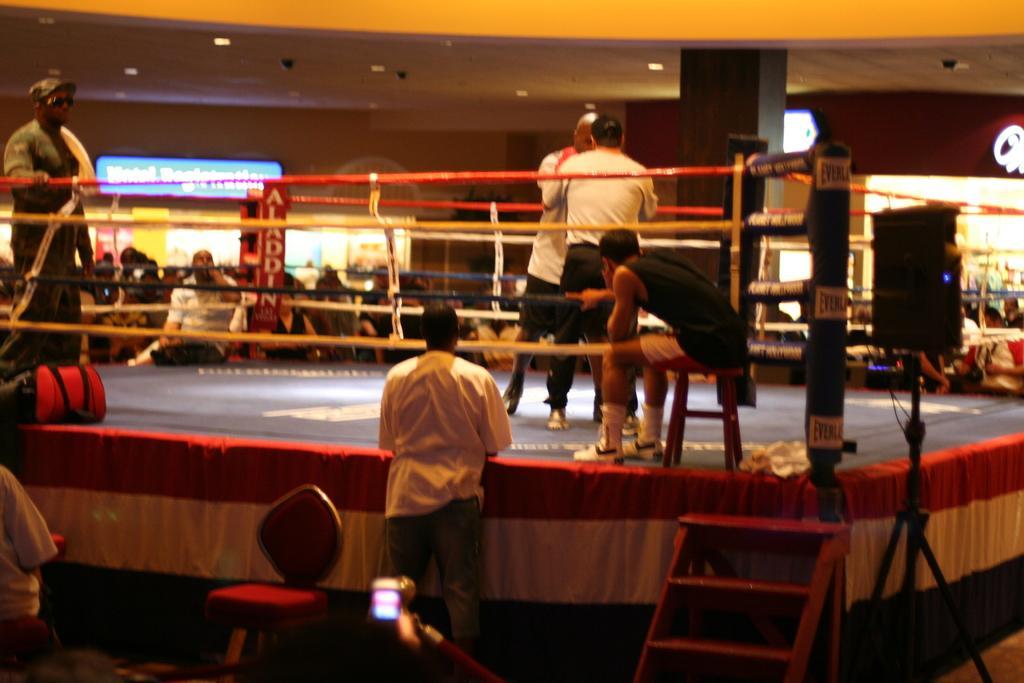In one or two sentences, can you explain what this image depicts? This picture shows the inner view of a building. There are some lights attached to the ceiling, one board with text, few objects attached to the wall, some objects attached to the ceiling, one boxing ring, some text with banners, some people are standing, some people are walking, two men sitting, one stool, one curtain around the boxing ring, two men boxing, some people are holding objects, one object with wire at the bottom of the image, one speaker with stand, one ladder, one bag, one object on the boxing ring, some objects in the background and the background is blurred. 